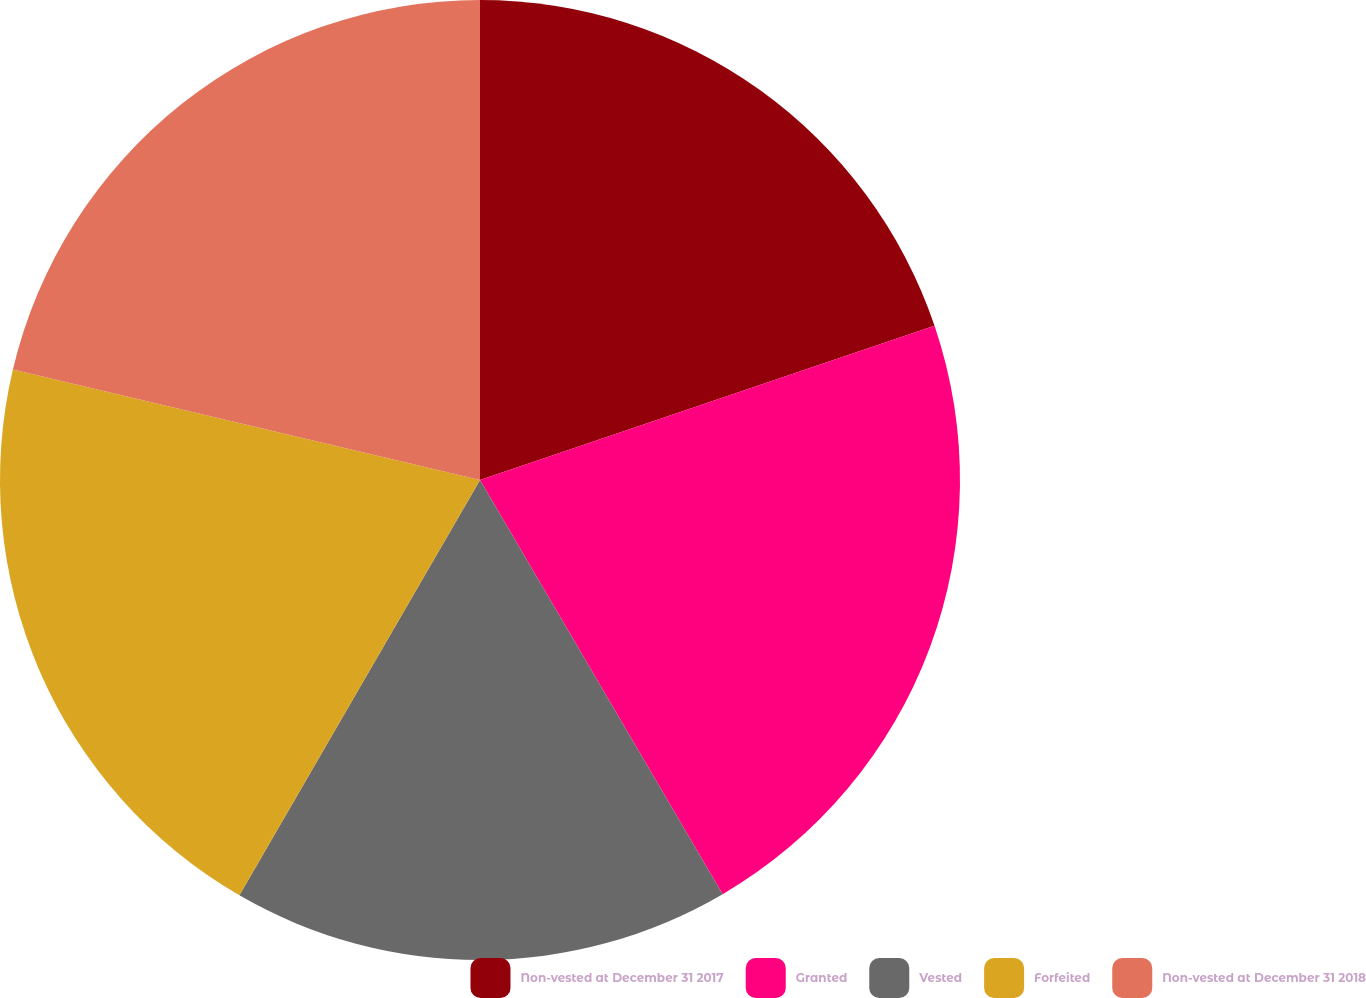Convert chart to OTSL. <chart><loc_0><loc_0><loc_500><loc_500><pie_chart><fcel>Non-vested at December 31 2017<fcel>Granted<fcel>Vested<fcel>Forfeited<fcel>Non-vested at December 31 2018<nl><fcel>19.79%<fcel>21.77%<fcel>16.79%<fcel>20.34%<fcel>21.3%<nl></chart> 